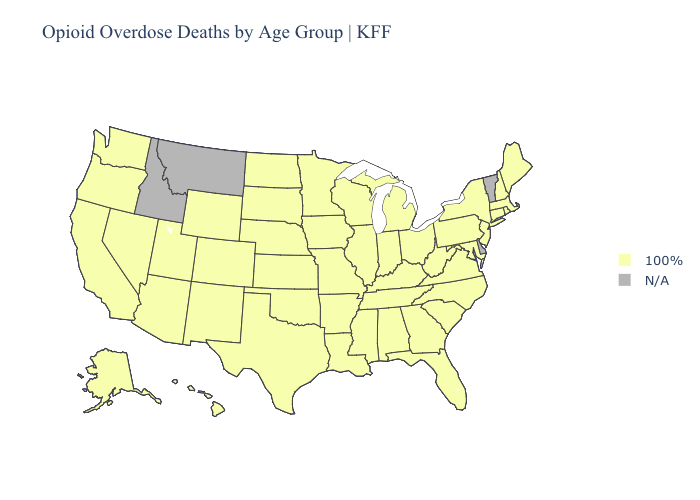What is the value of Louisiana?
Answer briefly. 100%. Name the states that have a value in the range N/A?
Quick response, please. Delaware, Idaho, Montana, Vermont. Name the states that have a value in the range N/A?
Be succinct. Delaware, Idaho, Montana, Vermont. Among the states that border Mississippi , which have the lowest value?
Short answer required. Alabama, Arkansas, Louisiana, Tennessee. Which states hav the highest value in the West?
Answer briefly. Alaska, Arizona, California, Colorado, Hawaii, Nevada, New Mexico, Oregon, Utah, Washington, Wyoming. Does the first symbol in the legend represent the smallest category?
Give a very brief answer. No. What is the value of Kentucky?
Quick response, please. 100%. What is the value of Maryland?
Keep it brief. 100%. What is the value of Connecticut?
Write a very short answer. 100%. Which states have the lowest value in the Northeast?
Give a very brief answer. Connecticut, Maine, Massachusetts, New Hampshire, New Jersey, New York, Pennsylvania, Rhode Island. What is the value of Utah?
Quick response, please. 100%. What is the highest value in the West ?
Give a very brief answer. 100%. Name the states that have a value in the range 100%?
Concise answer only. Alabama, Alaska, Arizona, Arkansas, California, Colorado, Connecticut, Florida, Georgia, Hawaii, Illinois, Indiana, Iowa, Kansas, Kentucky, Louisiana, Maine, Maryland, Massachusetts, Michigan, Minnesota, Mississippi, Missouri, Nebraska, Nevada, New Hampshire, New Jersey, New Mexico, New York, North Carolina, North Dakota, Ohio, Oklahoma, Oregon, Pennsylvania, Rhode Island, South Carolina, South Dakota, Tennessee, Texas, Utah, Virginia, Washington, West Virginia, Wisconsin, Wyoming. 